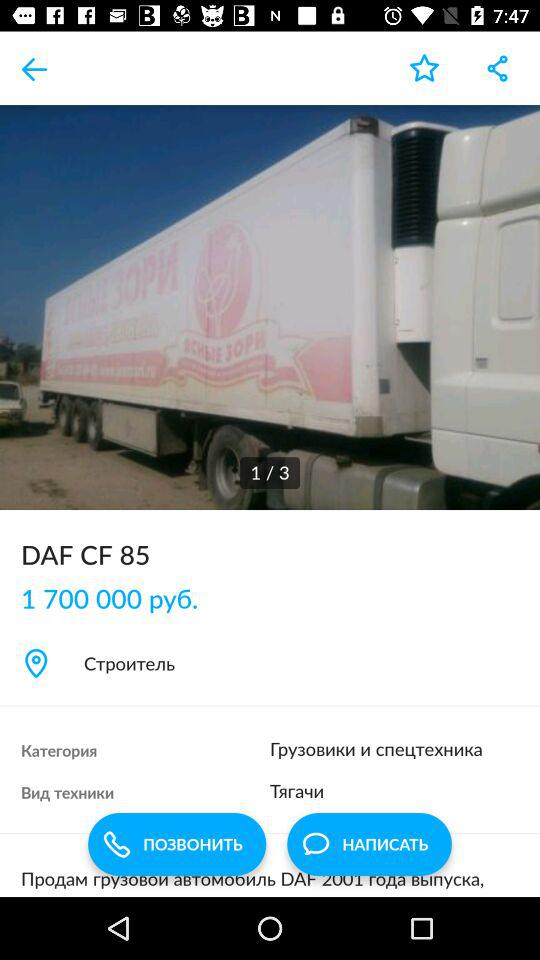What is the price of the DAF CF 85? 1 700 000 руб. 